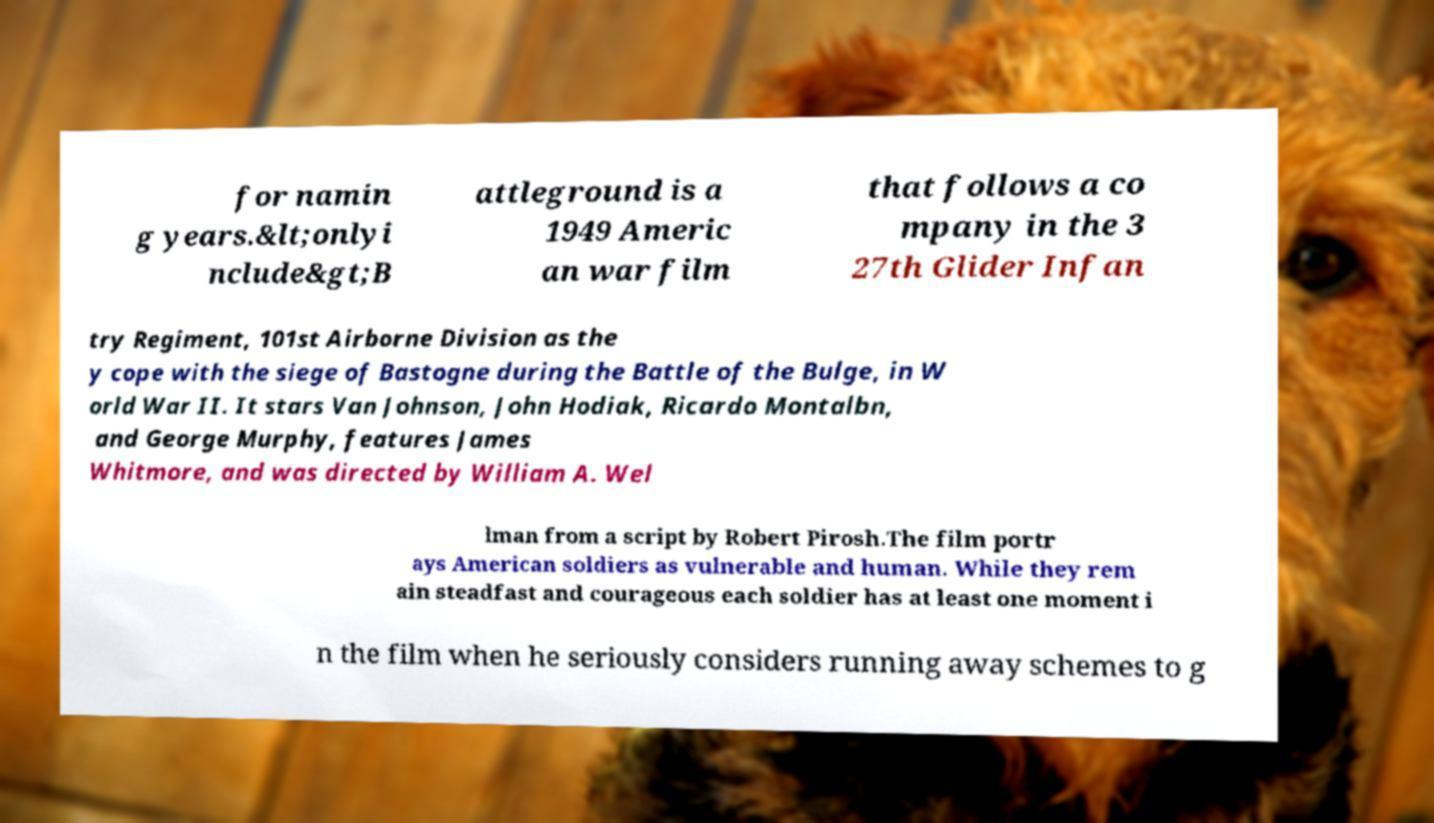There's text embedded in this image that I need extracted. Can you transcribe it verbatim? for namin g years.&lt;onlyi nclude&gt;B attleground is a 1949 Americ an war film that follows a co mpany in the 3 27th Glider Infan try Regiment, 101st Airborne Division as the y cope with the siege of Bastogne during the Battle of the Bulge, in W orld War II. It stars Van Johnson, John Hodiak, Ricardo Montalbn, and George Murphy, features James Whitmore, and was directed by William A. Wel lman from a script by Robert Pirosh.The film portr ays American soldiers as vulnerable and human. While they rem ain steadfast and courageous each soldier has at least one moment i n the film when he seriously considers running away schemes to g 